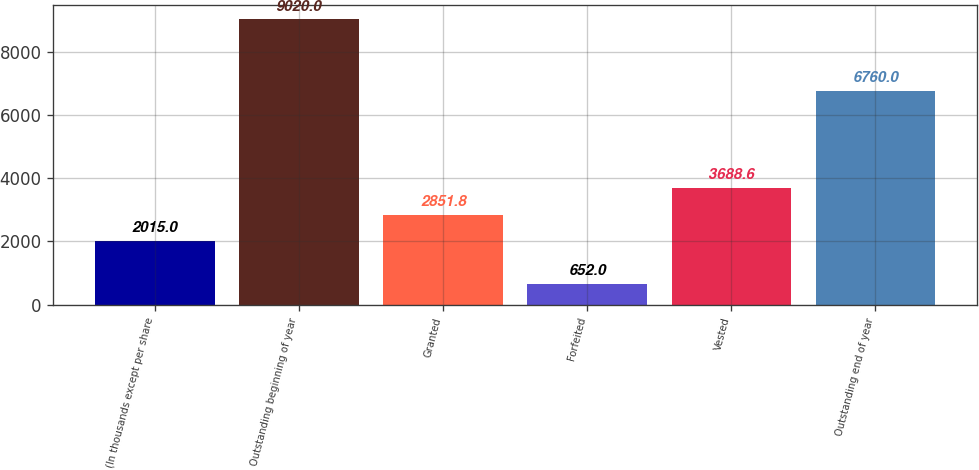<chart> <loc_0><loc_0><loc_500><loc_500><bar_chart><fcel>(In thousands except per share<fcel>Outstanding beginning of year<fcel>Granted<fcel>Forfeited<fcel>Vested<fcel>Outstanding end of year<nl><fcel>2015<fcel>9020<fcel>2851.8<fcel>652<fcel>3688.6<fcel>6760<nl></chart> 